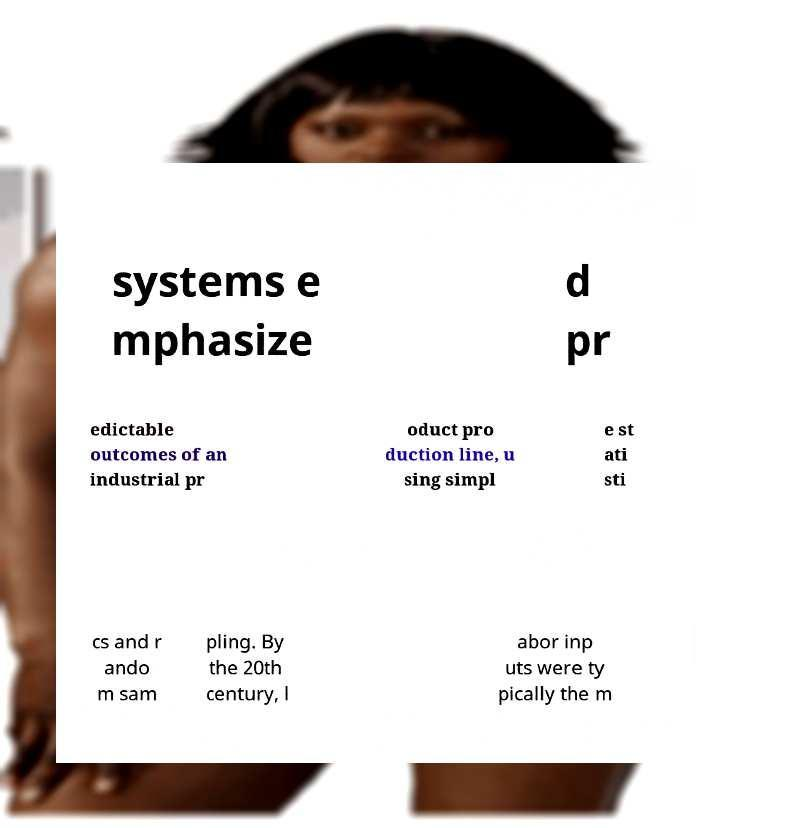Can you accurately transcribe the text from the provided image for me? systems e mphasize d pr edictable outcomes of an industrial pr oduct pro duction line, u sing simpl e st ati sti cs and r ando m sam pling. By the 20th century, l abor inp uts were ty pically the m 